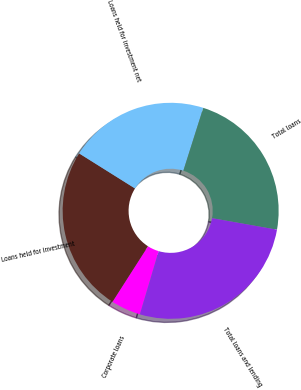<chart> <loc_0><loc_0><loc_500><loc_500><pie_chart><fcel>Corporate loans<fcel>Loans held for investment<fcel>Loans held for investment net<fcel>Total loans<fcel>Total loans and lending<nl><fcel>4.46%<fcel>24.86%<fcel>20.97%<fcel>22.91%<fcel>26.8%<nl></chart> 